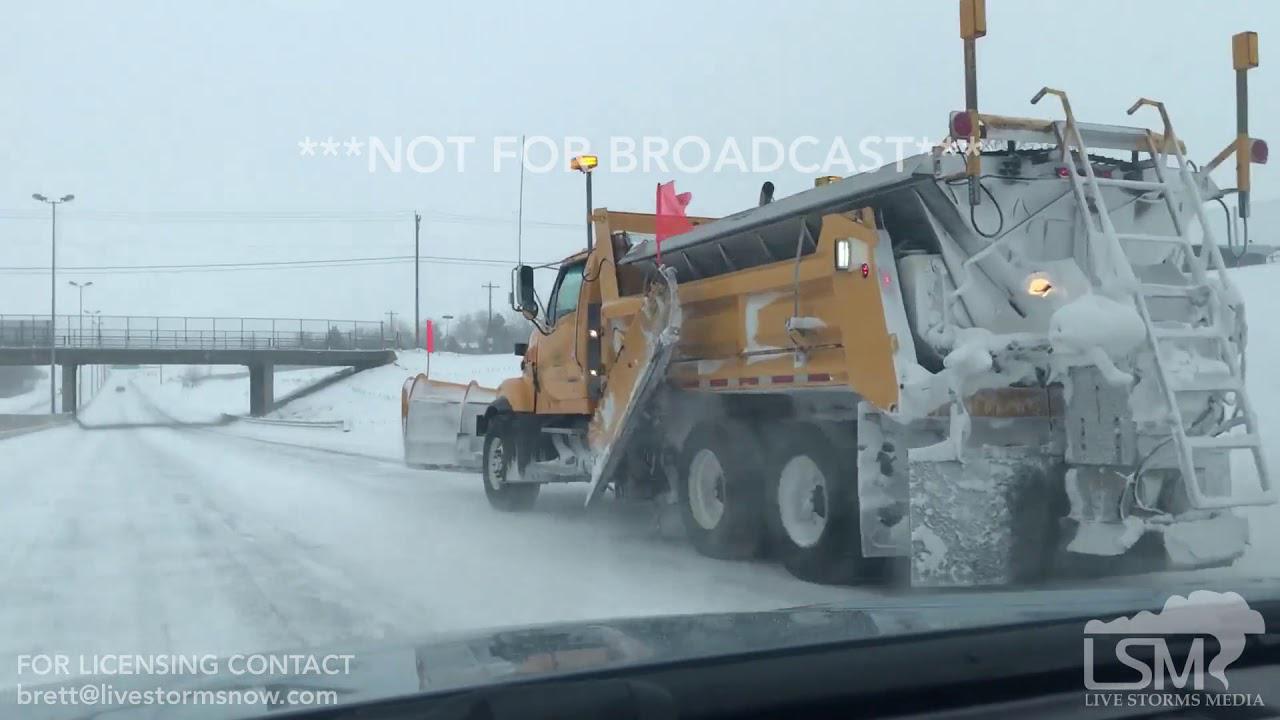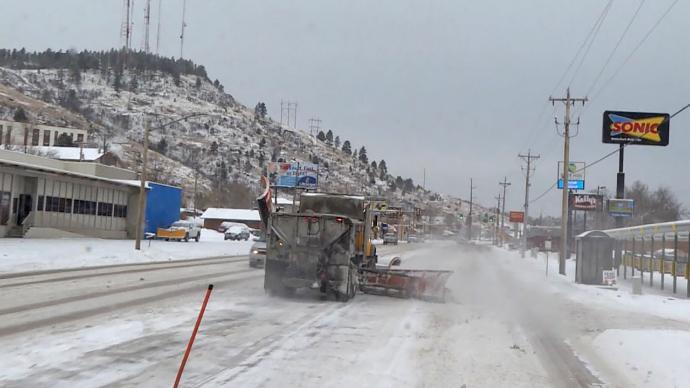The first image is the image on the left, the second image is the image on the right. Evaluate the accuracy of this statement regarding the images: "There is a line of plows in the right image and a single plow in the left.". Is it true? Answer yes or no. No. The first image is the image on the left, the second image is the image on the right. Given the left and right images, does the statement "Both images show the front side of a snow plow." hold true? Answer yes or no. No. 